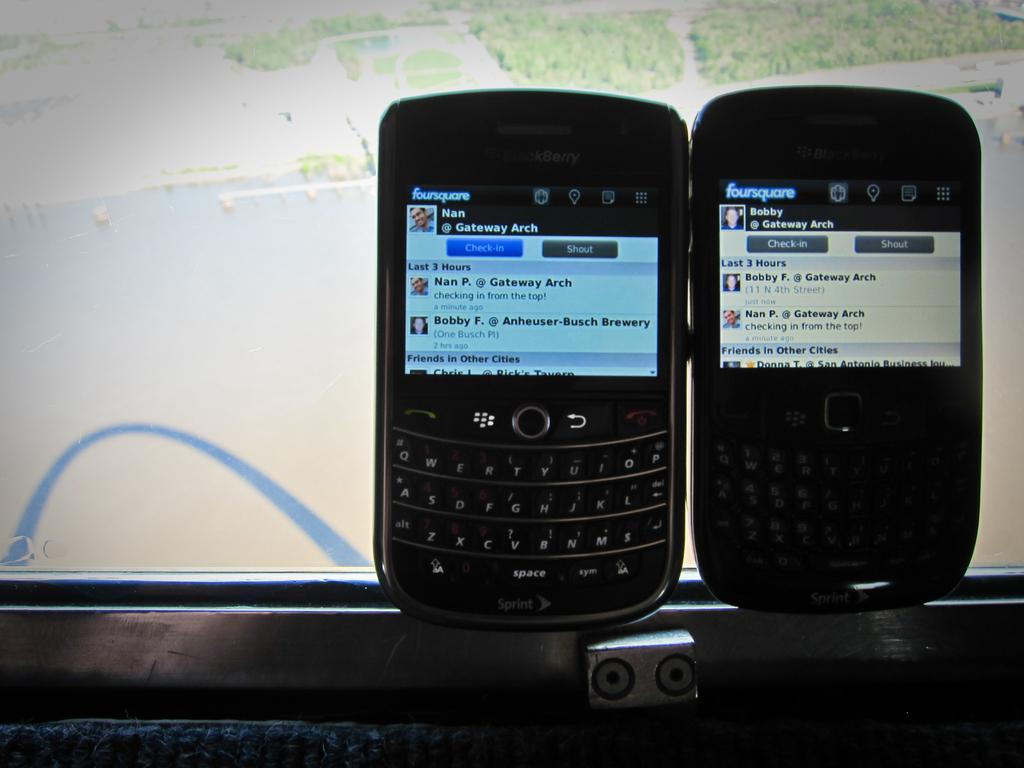<image>
Share a concise interpretation of the image provided. Two blackberry phones sit in a window, with both screens showing the foursquare page. 